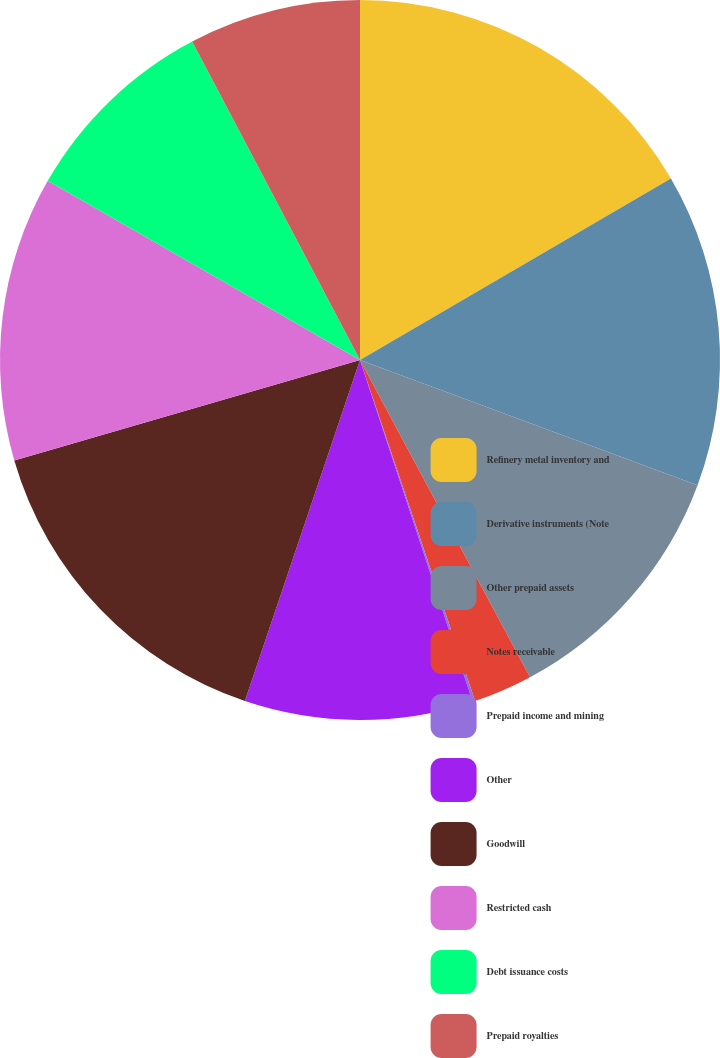Convert chart. <chart><loc_0><loc_0><loc_500><loc_500><pie_chart><fcel>Refinery metal inventory and<fcel>Derivative instruments (Note<fcel>Other prepaid assets<fcel>Notes receivable<fcel>Prepaid income and mining<fcel>Other<fcel>Goodwill<fcel>Restricted cash<fcel>Debt issuance costs<fcel>Prepaid royalties<nl><fcel>16.59%<fcel>14.06%<fcel>11.52%<fcel>2.65%<fcel>0.11%<fcel>10.25%<fcel>15.32%<fcel>12.79%<fcel>8.99%<fcel>7.72%<nl></chart> 